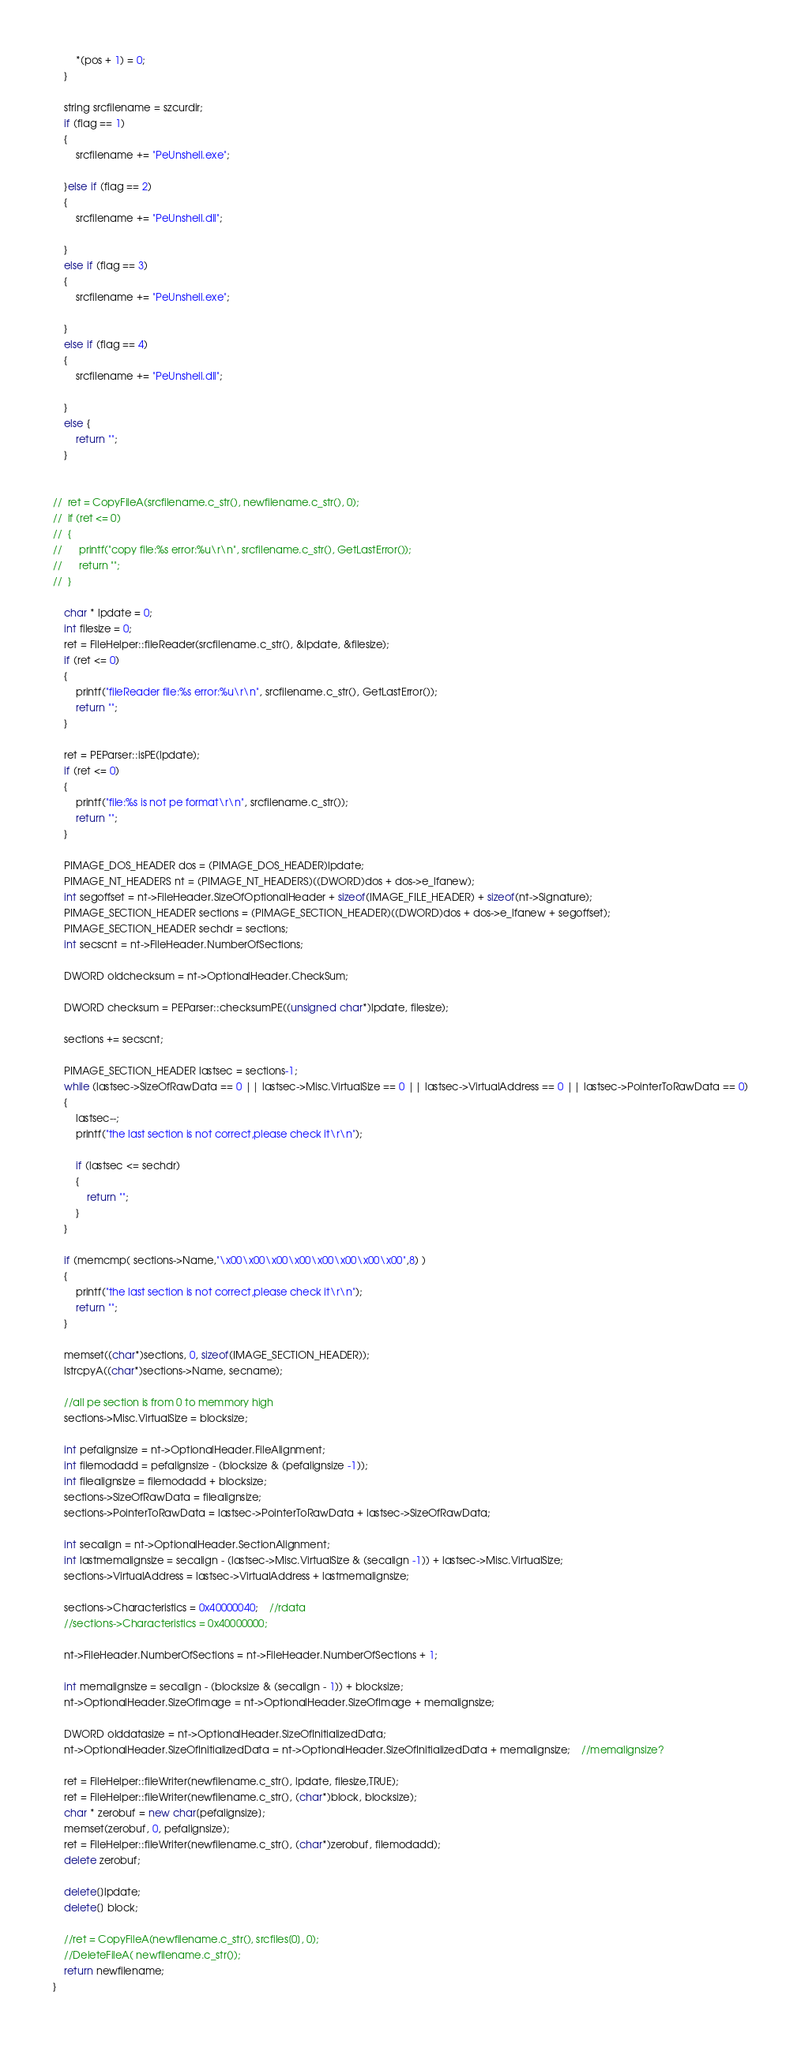Convert code to text. <code><loc_0><loc_0><loc_500><loc_500><_C++_>		*(pos + 1) = 0;
	}

	string srcfilename = szcurdir;
	if (flag == 1)
	{
		srcfilename += "PeUnshell.exe";
		
	}else if (flag == 2)
	{
		srcfilename += "PeUnshell.dll";

	}
	else if (flag == 3)
	{
		srcfilename += "PeUnshell.exe";

	}
	else if (flag == 4)
	{
		srcfilename += "PeUnshell.dll";

	}
	else {
		return "";
	}

	
// 	ret = CopyFileA(srcfilename.c_str(), newfilename.c_str(), 0);
// 	if (ret <= 0)
// 	{
// 		printf("copy file:%s error:%u\r\n", srcfilename.c_str(), GetLastError());
// 		return "";
// 	}

	char * lpdate = 0;
	int filesize = 0;
	ret = FileHelper::fileReader(srcfilename.c_str(), &lpdate, &filesize);
	if (ret <= 0)
	{
		printf("fileReader file:%s error:%u\r\n", srcfilename.c_str(), GetLastError());
		return "";
	}

	ret = PEParser::isPE(lpdate);
	if (ret <= 0)
	{
		printf("file:%s is not pe format\r\n", srcfilename.c_str());
		return "";
	}

	PIMAGE_DOS_HEADER dos = (PIMAGE_DOS_HEADER)lpdate;
	PIMAGE_NT_HEADERS nt = (PIMAGE_NT_HEADERS)((DWORD)dos + dos->e_lfanew);
	int segoffset = nt->FileHeader.SizeOfOptionalHeader + sizeof(IMAGE_FILE_HEADER) + sizeof(nt->Signature);
	PIMAGE_SECTION_HEADER sections = (PIMAGE_SECTION_HEADER)((DWORD)dos + dos->e_lfanew + segoffset);
	PIMAGE_SECTION_HEADER sechdr = sections;
	int secscnt = nt->FileHeader.NumberOfSections;

	DWORD oldchecksum = nt->OptionalHeader.CheckSum;

	DWORD checksum = PEParser::checksumPE((unsigned char*)lpdate, filesize);

	sections += secscnt;

	PIMAGE_SECTION_HEADER lastsec = sections-1;
	while (lastsec->SizeOfRawData == 0 || lastsec->Misc.VirtualSize == 0 || lastsec->VirtualAddress == 0 || lastsec->PointerToRawData == 0)
	{
		lastsec--;
		printf("the last section is not correct,please check it\r\n");

		if (lastsec <= sechdr)
		{
			return "";
		}
	}
	
	if (memcmp( sections->Name,"\x00\x00\x00\x00\x00\x00\x00\x00",8) )
	{
		printf("the last section is not correct,please check it\r\n");
		return "";
	}

	memset((char*)sections, 0, sizeof(IMAGE_SECTION_HEADER));
	lstrcpyA((char*)sections->Name, secname);

	//all pe section is from 0 to memmory high
	sections->Misc.VirtualSize = blocksize;

	int pefalignsize = nt->OptionalHeader.FileAlignment;
	int filemodadd = pefalignsize - (blocksize & (pefalignsize -1));
	int filealignsize = filemodadd + blocksize;
	sections->SizeOfRawData = filealignsize;
	sections->PointerToRawData = lastsec->PointerToRawData + lastsec->SizeOfRawData;
	
	int secalign = nt->OptionalHeader.SectionAlignment;
	int lastmemalignsize = secalign - (lastsec->Misc.VirtualSize & (secalign -1)) + lastsec->Misc.VirtualSize;
	sections->VirtualAddress = lastsec->VirtualAddress + lastmemalignsize;

	sections->Characteristics = 0x40000040;	//rdata
	//sections->Characteristics = 0x40000000;

	nt->FileHeader.NumberOfSections = nt->FileHeader.NumberOfSections + 1;

	int memalignsize = secalign - (blocksize & (secalign - 1)) + blocksize;
	nt->OptionalHeader.SizeOfImage = nt->OptionalHeader.SizeOfImage + memalignsize;

	DWORD olddatasize = nt->OptionalHeader.SizeOfInitializedData;
	nt->OptionalHeader.SizeOfInitializedData = nt->OptionalHeader.SizeOfInitializedData + memalignsize;	//memalignsize?

	ret = FileHelper::fileWriter(newfilename.c_str(), lpdate, filesize,TRUE);
	ret = FileHelper::fileWriter(newfilename.c_str(), (char*)block, blocksize);
	char * zerobuf = new char[pefalignsize];
	memset(zerobuf, 0, pefalignsize);
	ret = FileHelper::fileWriter(newfilename.c_str(), (char*)zerobuf, filemodadd);
	delete zerobuf;

	delete[]lpdate;
	delete[] block;

	//ret = CopyFileA(newfilename.c_str(), srcfiles[0], 0);
	//DeleteFileA( newfilename.c_str());
	return newfilename;
}</code> 